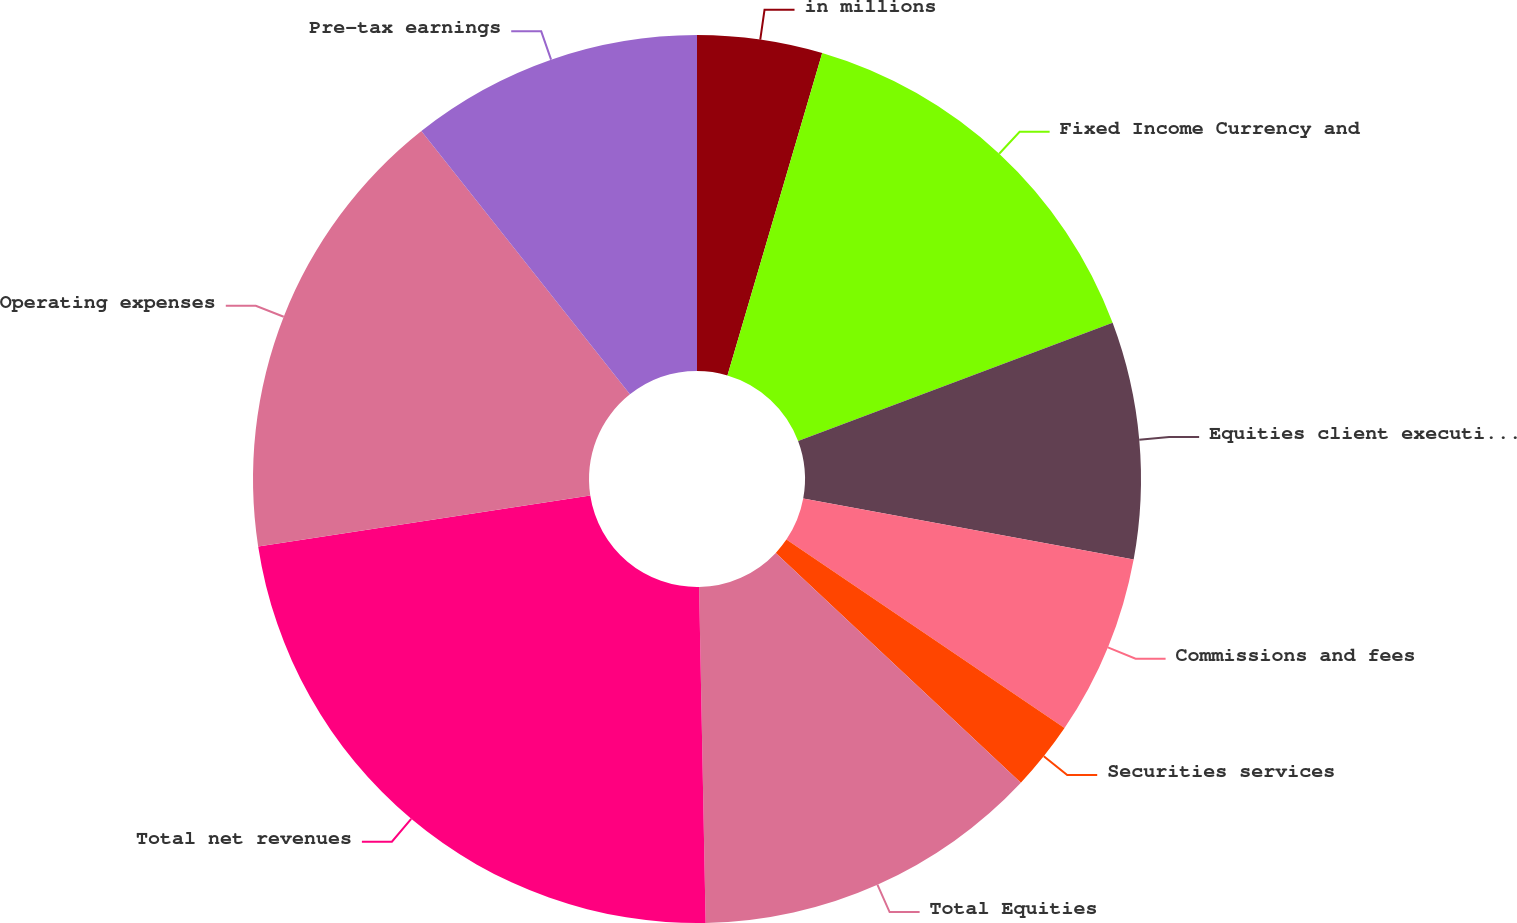Convert chart to OTSL. <chart><loc_0><loc_0><loc_500><loc_500><pie_chart><fcel>in millions<fcel>Fixed Income Currency and<fcel>Equities client execution 1<fcel>Commissions and fees<fcel>Securities services<fcel>Total Equities<fcel>Total net revenues<fcel>Operating expenses<fcel>Pre-tax earnings<nl><fcel>4.55%<fcel>14.73%<fcel>8.62%<fcel>6.58%<fcel>2.51%<fcel>12.7%<fcel>22.88%<fcel>16.77%<fcel>10.66%<nl></chart> 